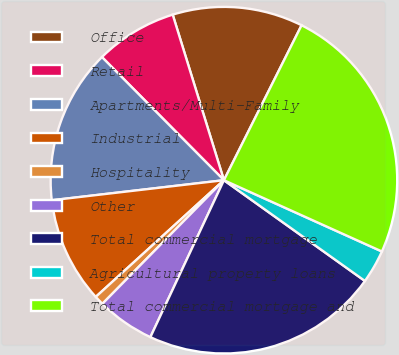Convert chart. <chart><loc_0><loc_0><loc_500><loc_500><pie_chart><fcel>Office<fcel>Retail<fcel>Apartments/Multi-Family<fcel>Industrial<fcel>Hospitality<fcel>Other<fcel>Total commercial mortgage<fcel>Agricultural property loans<fcel>Total commercial mortgage and<nl><fcel>12.17%<fcel>7.65%<fcel>14.42%<fcel>9.91%<fcel>0.88%<fcel>5.39%<fcel>22.1%<fcel>3.13%<fcel>24.35%<nl></chart> 